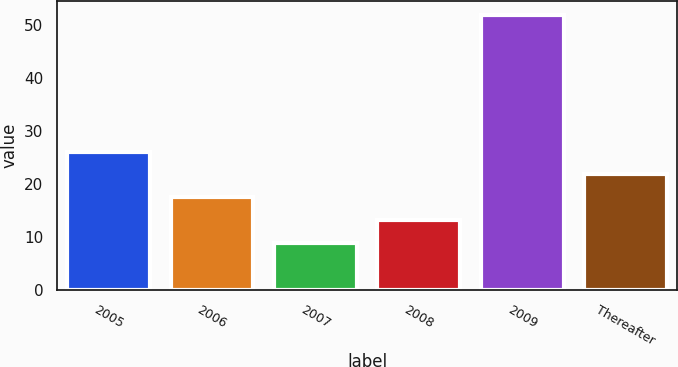<chart> <loc_0><loc_0><loc_500><loc_500><bar_chart><fcel>2005<fcel>2006<fcel>2007<fcel>2008<fcel>2009<fcel>Thereafter<nl><fcel>26.14<fcel>17.52<fcel>8.9<fcel>13.21<fcel>52<fcel>21.83<nl></chart> 